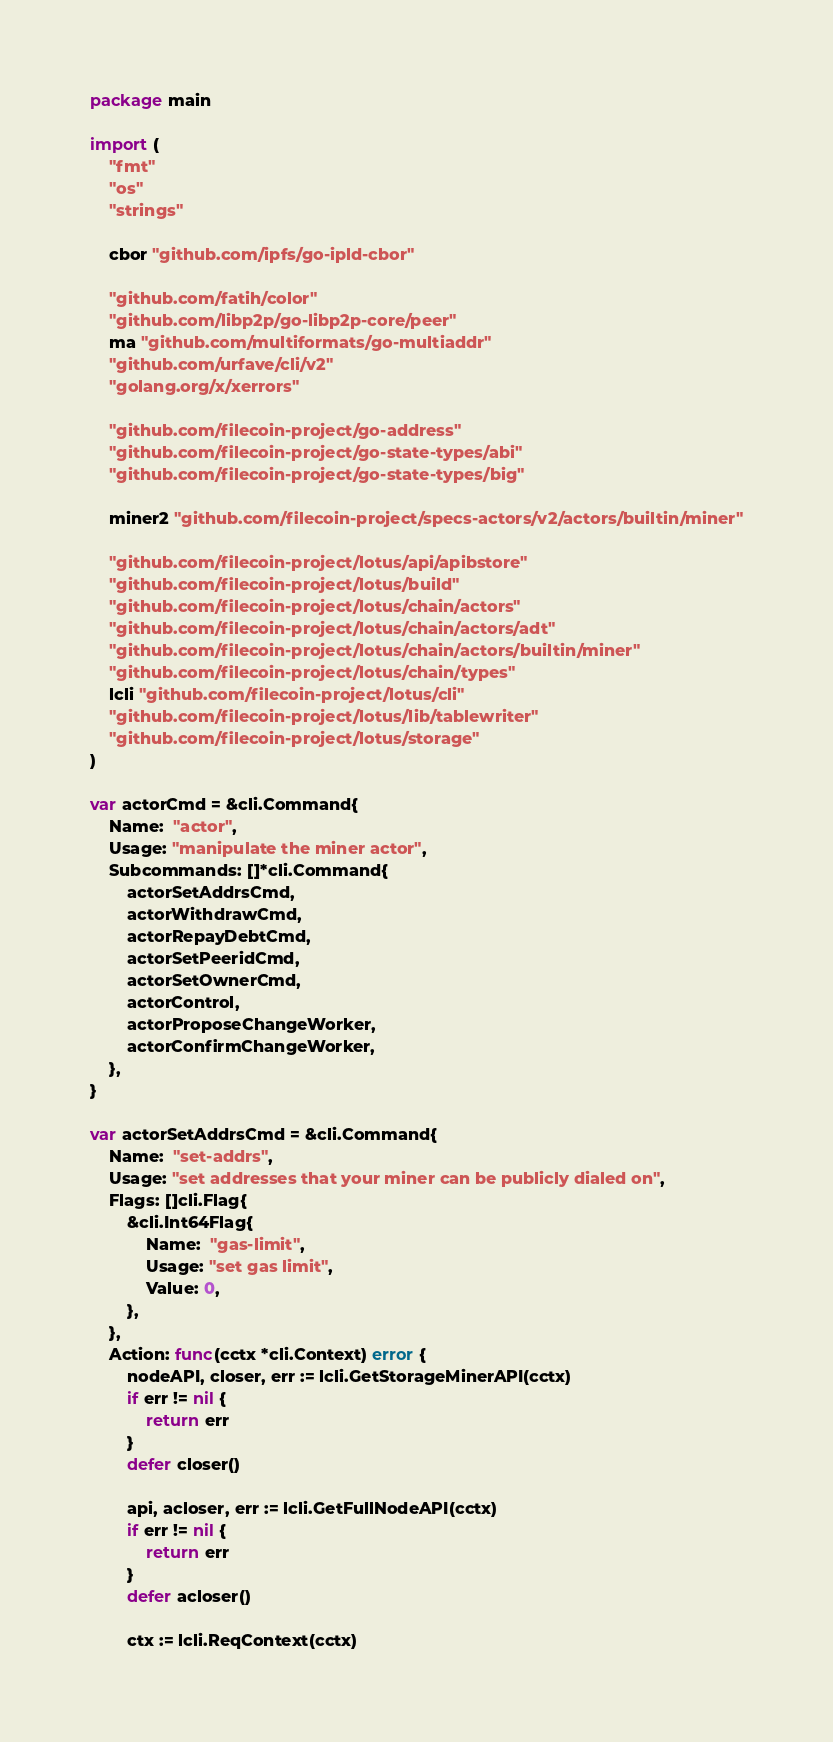<code> <loc_0><loc_0><loc_500><loc_500><_Go_>package main

import (
	"fmt"
	"os"
	"strings"

	cbor "github.com/ipfs/go-ipld-cbor"

	"github.com/fatih/color"
	"github.com/libp2p/go-libp2p-core/peer"
	ma "github.com/multiformats/go-multiaddr"
	"github.com/urfave/cli/v2"
	"golang.org/x/xerrors"

	"github.com/filecoin-project/go-address"
	"github.com/filecoin-project/go-state-types/abi"
	"github.com/filecoin-project/go-state-types/big"

	miner2 "github.com/filecoin-project/specs-actors/v2/actors/builtin/miner"

	"github.com/filecoin-project/lotus/api/apibstore"
	"github.com/filecoin-project/lotus/build"
	"github.com/filecoin-project/lotus/chain/actors"
	"github.com/filecoin-project/lotus/chain/actors/adt"
	"github.com/filecoin-project/lotus/chain/actors/builtin/miner"
	"github.com/filecoin-project/lotus/chain/types"
	lcli "github.com/filecoin-project/lotus/cli"
	"github.com/filecoin-project/lotus/lib/tablewriter"
	"github.com/filecoin-project/lotus/storage"
)

var actorCmd = &cli.Command{
	Name:  "actor",
	Usage: "manipulate the miner actor",
	Subcommands: []*cli.Command{
		actorSetAddrsCmd,
		actorWithdrawCmd,
		actorRepayDebtCmd,
		actorSetPeeridCmd,
		actorSetOwnerCmd,
		actorControl,
		actorProposeChangeWorker,
		actorConfirmChangeWorker,
	},
}

var actorSetAddrsCmd = &cli.Command{
	Name:  "set-addrs",
	Usage: "set addresses that your miner can be publicly dialed on",
	Flags: []cli.Flag{
		&cli.Int64Flag{
			Name:  "gas-limit",
			Usage: "set gas limit",
			Value: 0,
		},
	},
	Action: func(cctx *cli.Context) error {
		nodeAPI, closer, err := lcli.GetStorageMinerAPI(cctx)
		if err != nil {
			return err
		}
		defer closer()

		api, acloser, err := lcli.GetFullNodeAPI(cctx)
		if err != nil {
			return err
		}
		defer acloser()

		ctx := lcli.ReqContext(cctx)
</code> 